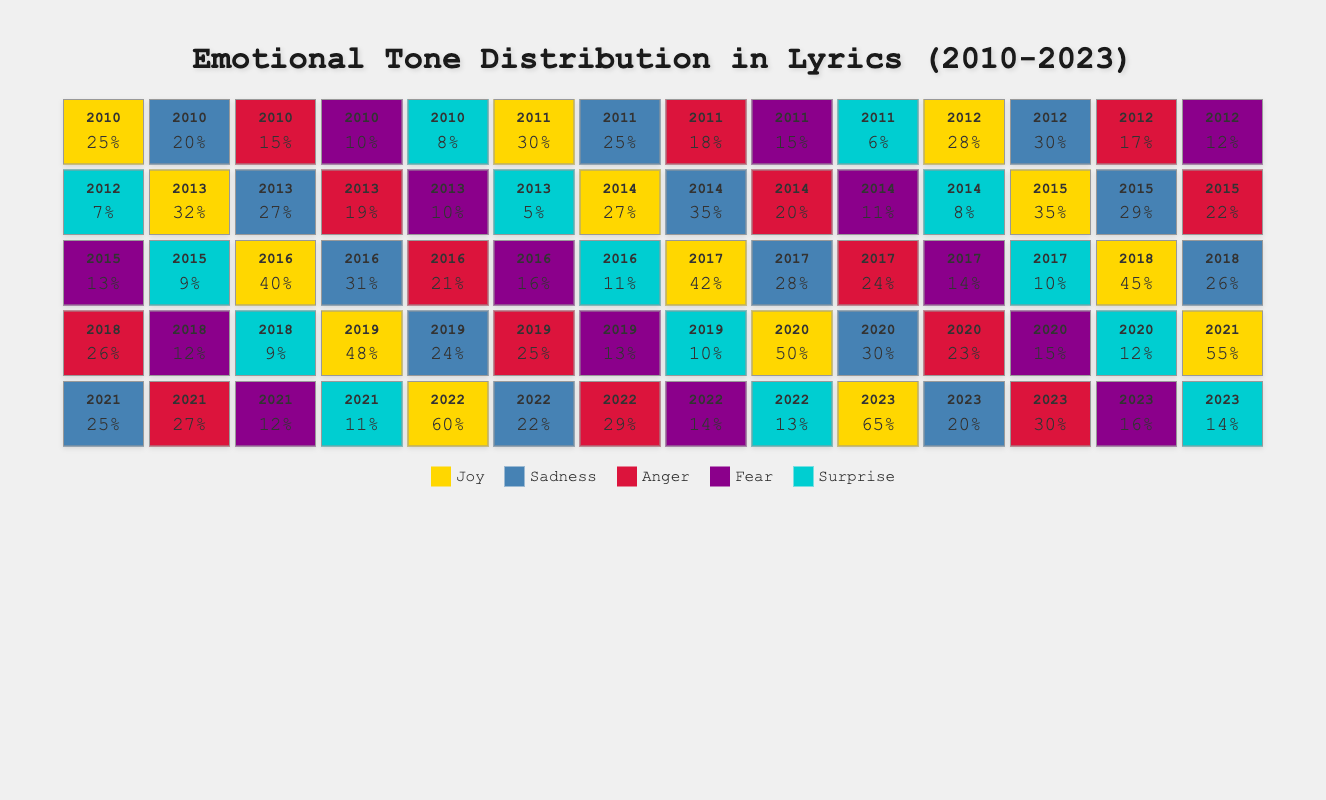What is the emotional tone with the highest value in 2023? In 2023, the emotional tones are Joy (65%), Sadness (20%), Anger (30%), Fear (16%), and Surprise (14%). The highest value among these is Joy at 65%.
Answer: Joy Which year had the highest percentage of Sadness in lyrics? Reviewing the Sadness percentages from 2010 to 2023, the highest percentage is 35%, observed in 2014.
Answer: 2014 What is the average percentage of Fear from 2010 to 2023? The Fear percentages for the years are [10, 15, 12, 10, 11, 13, 16, 14, 12, 13, 15, 12, 14, 16]. Summing these gives 10 + 15 + 12 + 10 + 11 + 13 + 16 + 14 + 12 + 13 + 15 + 12 + 14 + 16 = 186. Dividing by the number of years (14), the average is 186/14 = 13.29, which rounds to approximately 13%.
Answer: 13% Is the percentage of Anger higher in 2022 than in 2020? In 2022, the percentage of Anger is 29%, while in 2020 it is 23%. Since 29% is greater than 23%, the statement is true.
Answer: Yes What is the difference in percentage of Joy between 2016 and 2020? The percentages of Joy in 2016 and 2020 are 40% and 50%, respectively. The difference is calculated by subtracting 40% from 50%, which gives 50 - 40 = 10%.
Answer: 10% In which year did Surprise have its lowest percentage? When analyzing the Surprise percentages, we see [8, 6, 7, 5, 8, 9, 11, 10, 9, 10, 12, 11, 13, 14]. The lowest percentage is 5%, which occurred in 2013.
Answer: 2013 What was the total percentage of Joy from 2010 to 2015? The Joy percentages from 2010 to 2015 are [25, 30, 28, 32, 27, 35]. Adding these values results in 25 + 30 + 28 + 32 + 27 + 35 = 207.
Answer: 207 In 2019, which emotional tone had a higher percentage: Fear or Anger? For 2019, Anger had a percentage of 25% and Fear had 13%. Since 25% is greater than 13%, Anger is higher than Fear.
Answer: Anger What emotional tone saw an increase every year from 2010 to 2023? Analyzing the data, Joy exhibits a consistent increase from 25% in 2010 to 65% in 2023. Other tones fluctuate, but Joy consistently rises.
Answer: Joy 